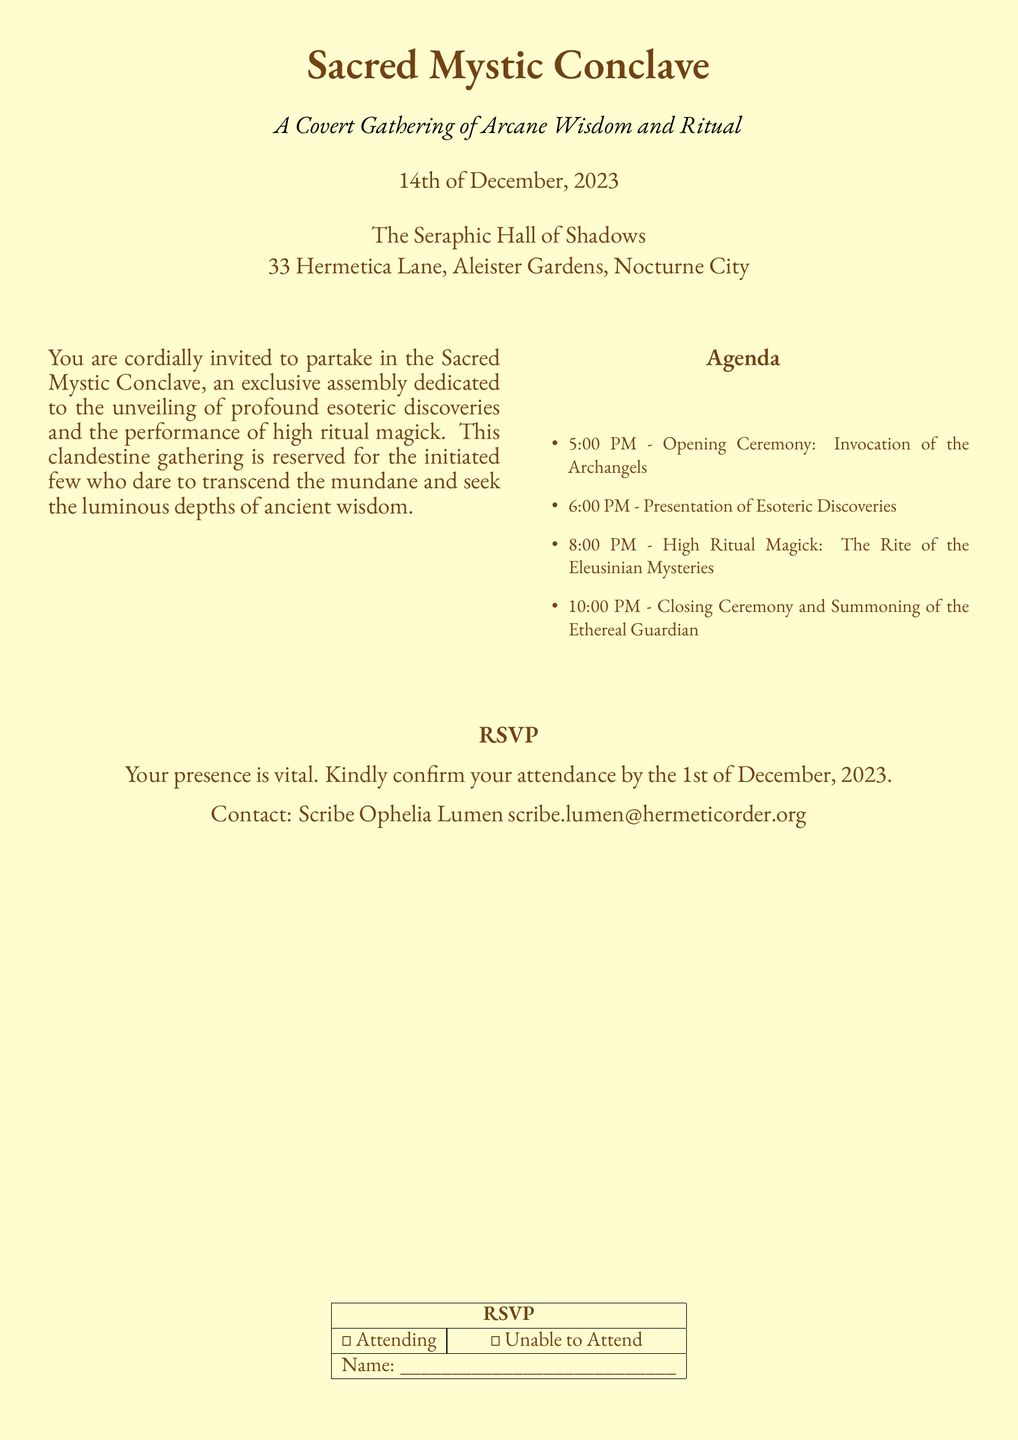what is the date of the Sacred Mystic Conclave? The date is explicitly mentioned in the invitation as "14th of December, 2023."
Answer: 14th of December, 2023 where is the Sacred Mystic Conclave being held? The location is provided in the document as "The Seraphic Hall of Shadows."
Answer: The Seraphic Hall of Shadows who should be contacted for RSVP? The document specifies "Scribe Ophelia Lumen" as the contact person for RSVP.
Answer: Scribe Ophelia Lumen when is the deadline to confirm attendance? The RSVP section states that confirmation is needed by "the 1st of December, 2023."
Answer: the 1st of December, 2023 what time does the High Ritual Magick begin? The agenda details that the High Ritual Magick event starts at "8:00 PM."
Answer: 8:00 PM how many main events are listed in the agenda? The agenda contains four distinctive events throughout the evening, as outlined in the provided list.
Answer: 4 what is the theme of the gathering? The document describes the meeting as "A Covert Gathering of Arcane Wisdom and Ritual," indicating its thematic focus.
Answer: A Covert Gathering of Arcane Wisdom and Ritual what options are provided for attendance confirmation? The RSVP section includes two options: "Attending" or "Unable to Attend."
Answer: Attending or Unable to Attend 